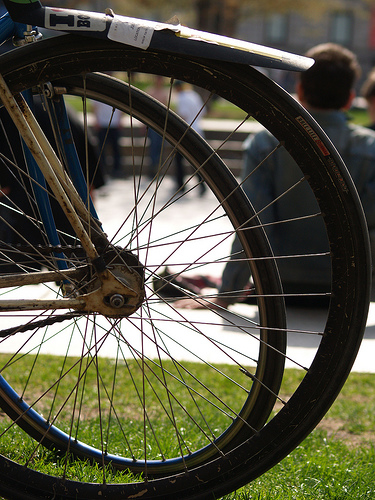<image>
Is there a man to the right of the cycle? No. The man is not to the right of the cycle. The horizontal positioning shows a different relationship. 